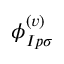<formula> <loc_0><loc_0><loc_500><loc_500>\phi _ { I p \sigma } ^ { ( v ) }</formula> 